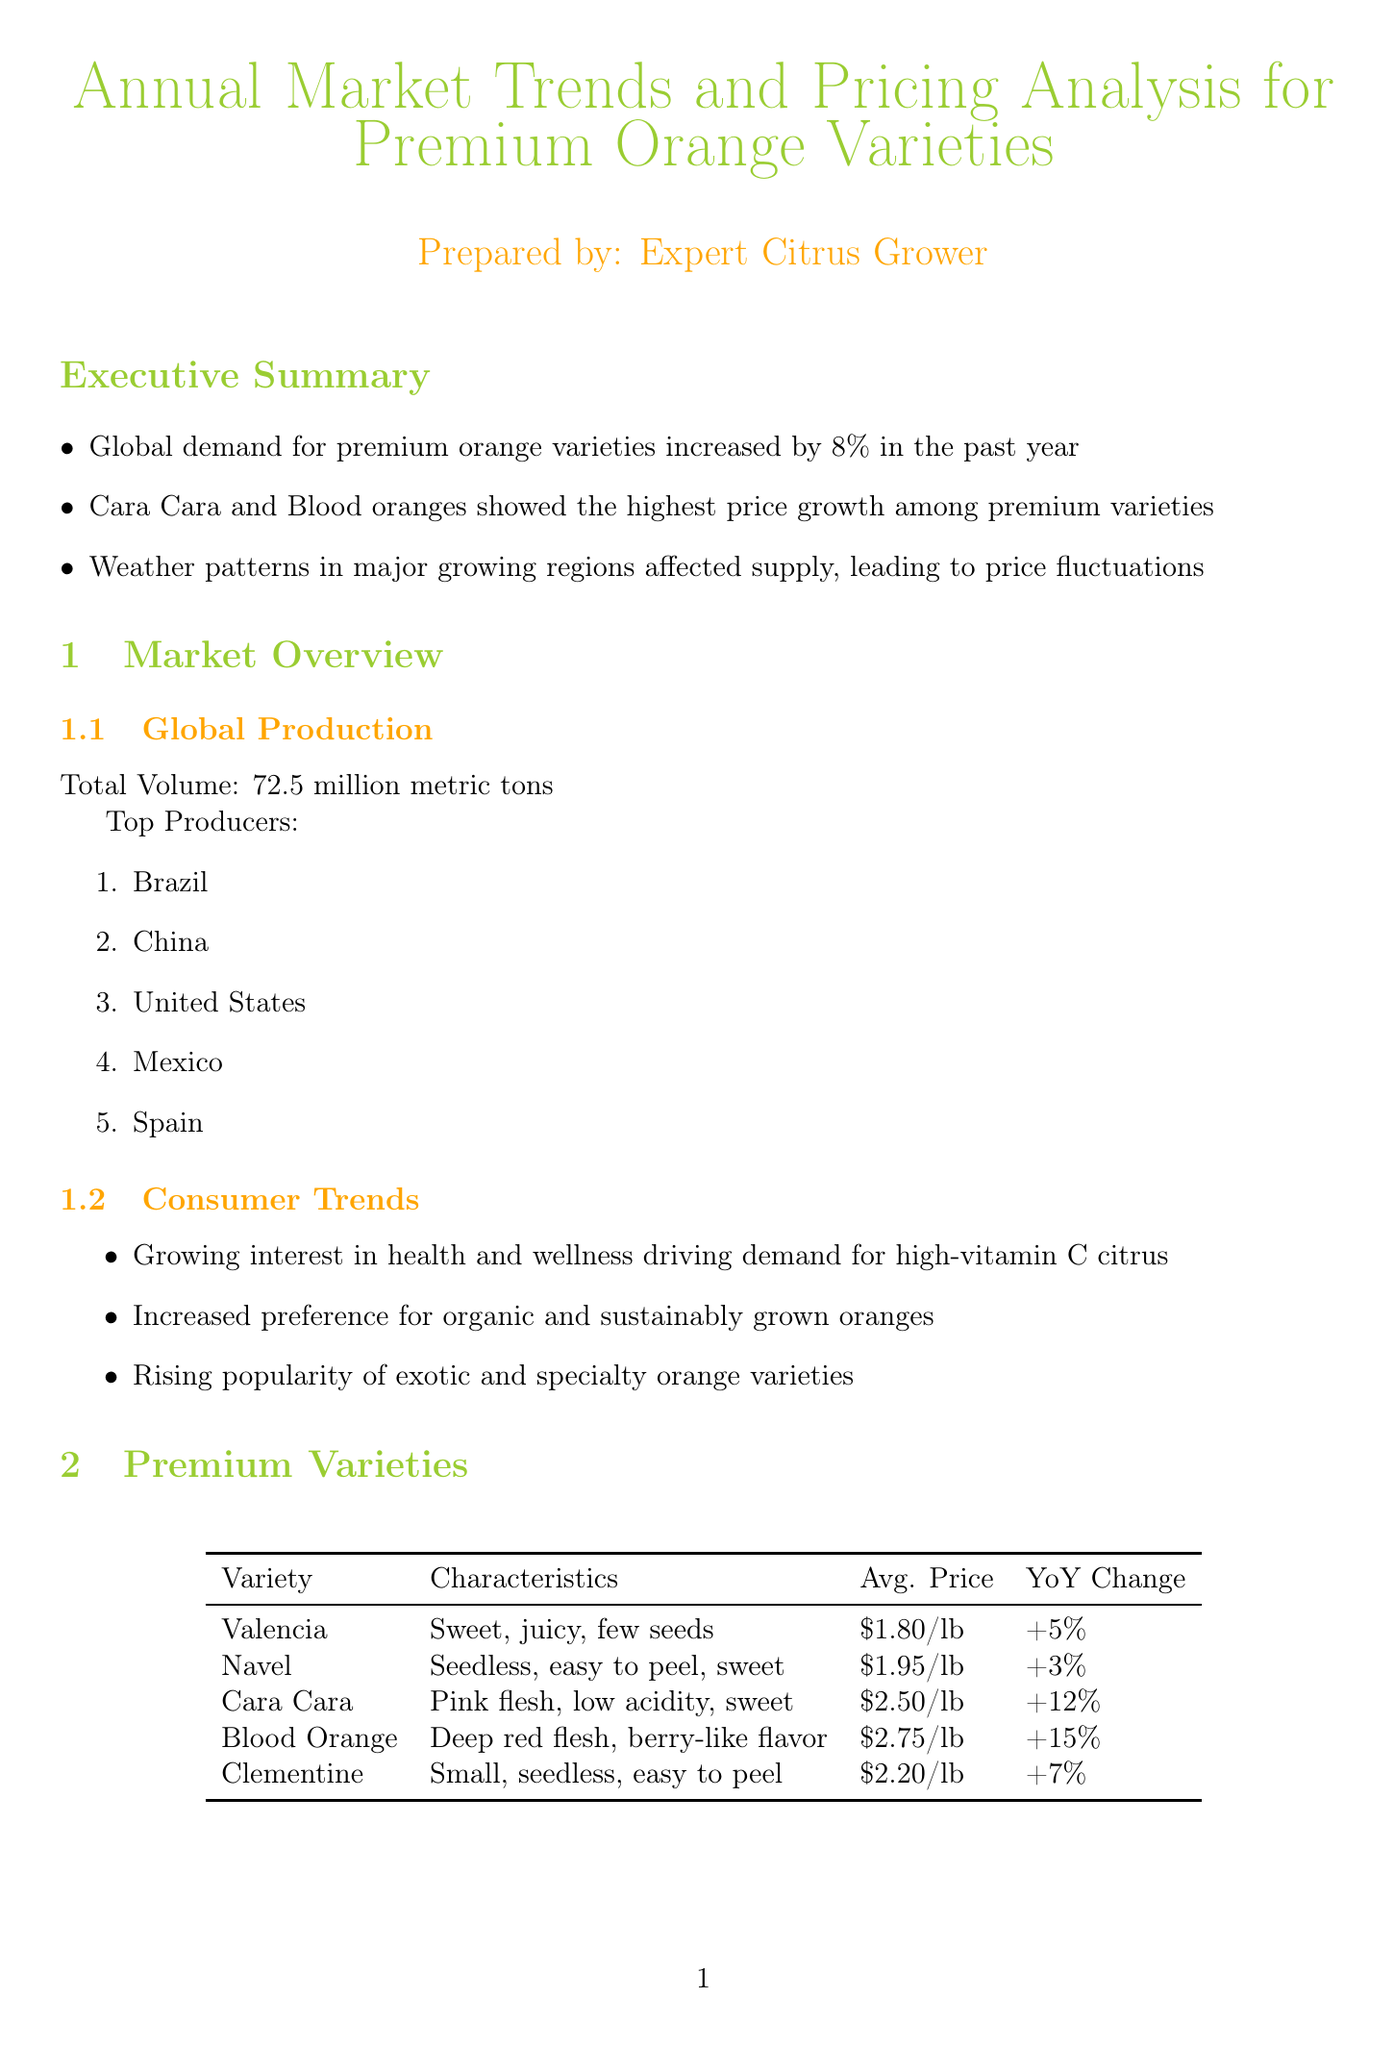What was the global demand increase for premium orange varieties last year? The document states that global demand for premium orange varieties increased by 8% in the past year.
Answer: 8% Which orange variety had the highest average price? The report indicates that Blood Orange had the highest average price at $2.75 per pound.
Answer: $2.75 per pound What are the major production challenges faced in California? The document lists drought and labor shortages as major production challenges in California.
Answer: Drought, Labor shortages What percentage of the US premium orange market does California hold? According to the report, California holds 65% of the US premium orange market.
Answer: 65% Which distribution channel has the smallest market share? The report indicates that Food Service has the smallest market share at 8%.
Answer: 8% What emerging trend is noted in the future outlook? The document mentions that there is an increased demand for seedless varieties as an emerging trend.
Answer: Increased demand for seedless varieties Which premium orange variety showed the highest year-over-year change? The report states that Blood Orange showed the highest year-over-year change at +15%.
Answer: +15% What is the average price of Cara Cara oranges? The average price of Cara Cara oranges, according to the report, is $2.50 per pound.
Answer: $2.50 per pound 